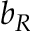<formula> <loc_0><loc_0><loc_500><loc_500>b _ { R }</formula> 